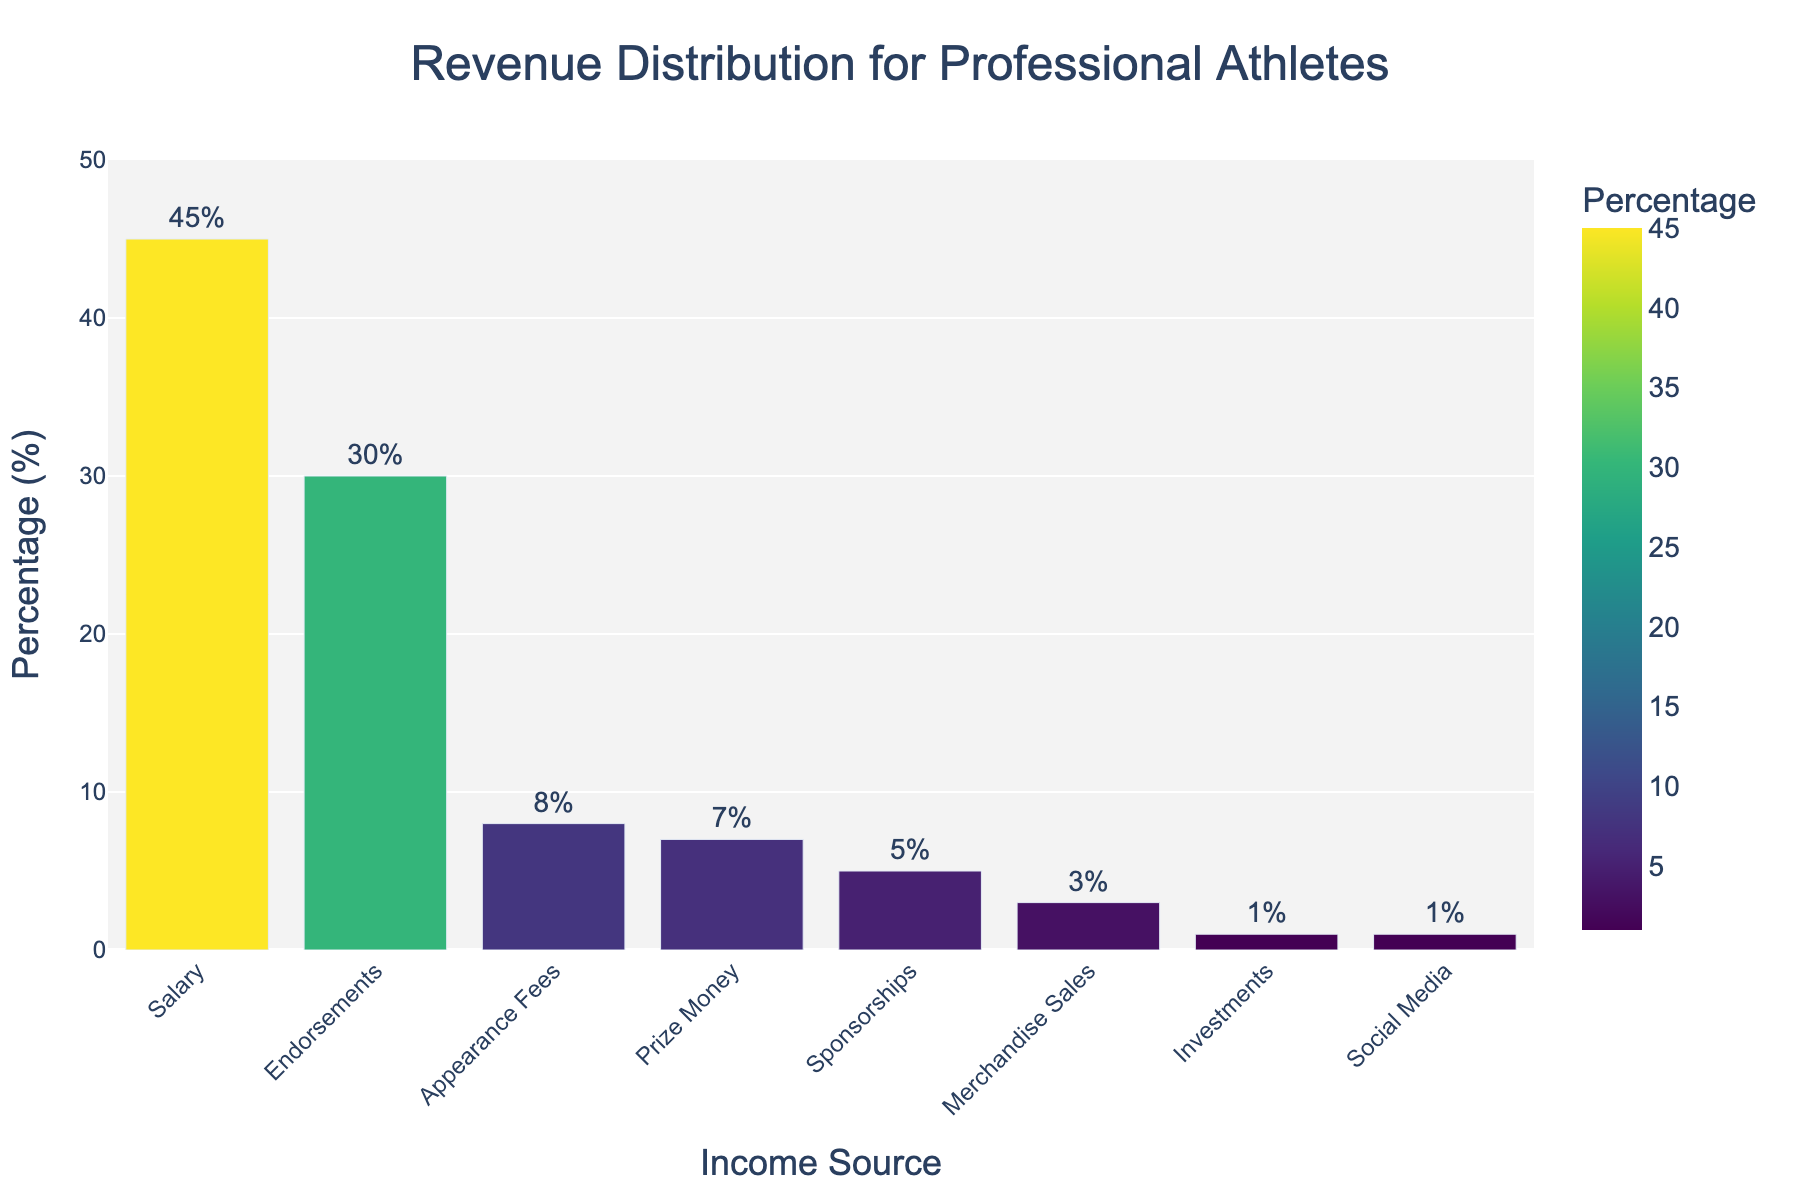Which income source has the highest percentage? The bar with the highest value is "Salary" which stands out visibly, reaching 45%.
Answer: Salary What is the combined percentage of Endorsements and Prize Money? The percentage for Endorsements is 30% and for Prize Money is 7%. Adding both, 30 + 7 = 37.
Answer: 37 How much higher is the percentage of Salary compared to the percentage of Sponsorships? The percentage for Salary is 45% and for Sponsorships is 5%. The difference is 45 - 5 = 40.
Answer: 40 What is the smallest source of income, and what percentage does it contribute? The shortest bar represents both "Investments" and "Social Media," each contributing 1%.
Answer: Investments and Social Media, 1% Which income sources contribute more than 10% each? The bars for Salary (45%) and Endorsements (30%) both exceed 10%.
Answer: Salary and Endorsements What is the total percentage contributed by the sources with less than 5% each? The sources with less than 5% are Sponsorships (5%), Merchandise Sales (3%), Investments (1%), and Social Media (1%). Adding these, 5 + 3 + 1 + 1 = 10.
Answer: 10 Compare the total percentage of Appearance Fees and Prize Money to that of Salary. Is it higher, lower, or the same? The combined percentage of Appearance Fees (8%) and Prize Money (7%) is 15%. This is lower than the percentage of Salary at 45%.
Answer: Lower If the total revenue is $1,000,000, how much revenue does the Endorsements category generate? With Endorsements at 30%, multiply $1,000,000 by 0.30. This gives $300,000.
Answer: $300,000 